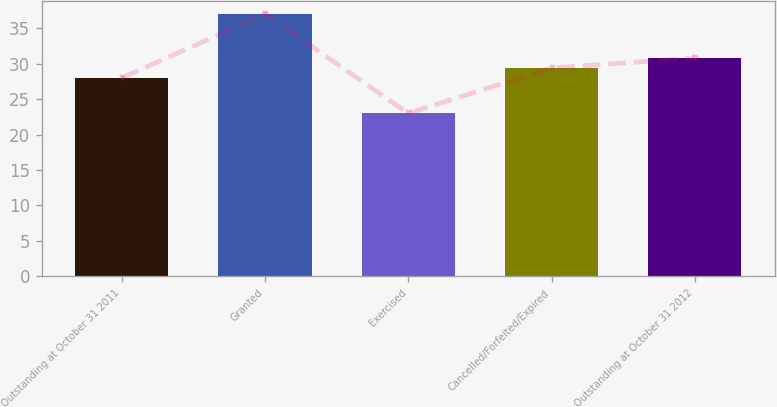Convert chart to OTSL. <chart><loc_0><loc_0><loc_500><loc_500><bar_chart><fcel>Outstanding at October 31 2011<fcel>Granted<fcel>Exercised<fcel>Cancelled/Forfeited/Expired<fcel>Outstanding at October 31 2012<nl><fcel>28<fcel>37<fcel>23<fcel>29.4<fcel>30.8<nl></chart> 